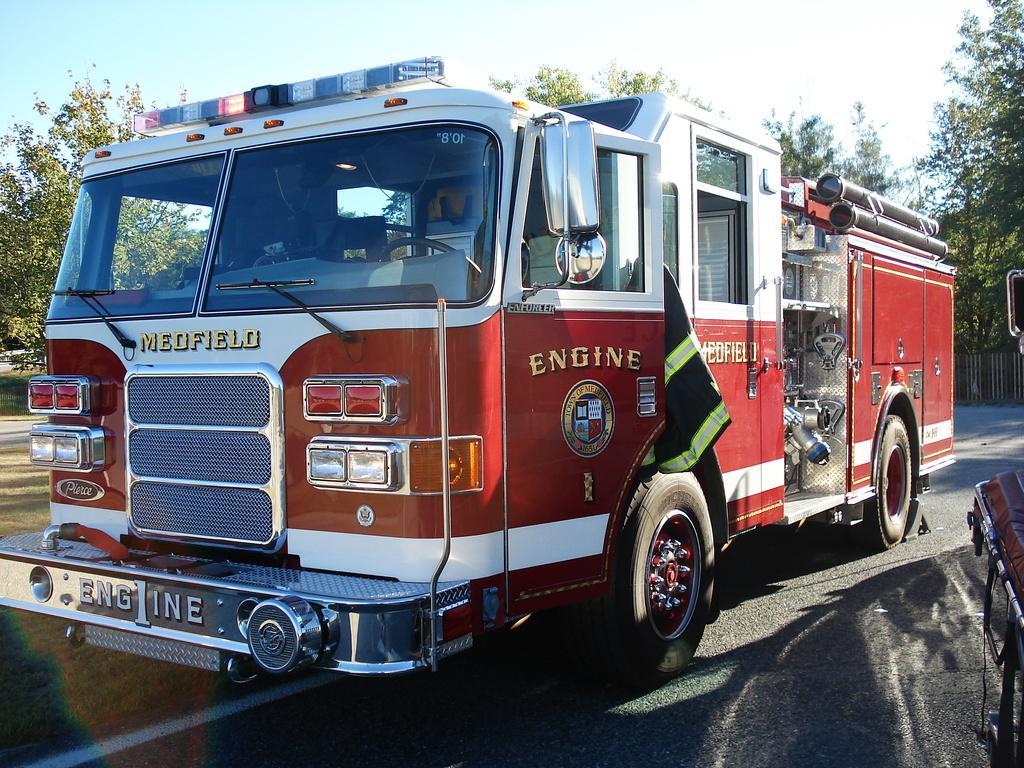Can you describe this image briefly? We can see there is a vehicle on the road is in the middle of this image. There are some trees in the background. There is a sky at the top of this image. 